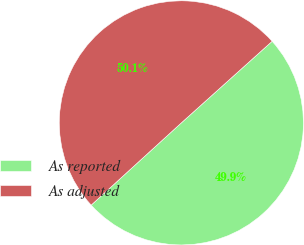Convert chart. <chart><loc_0><loc_0><loc_500><loc_500><pie_chart><fcel>As reported<fcel>As adjusted<nl><fcel>49.88%<fcel>50.12%<nl></chart> 